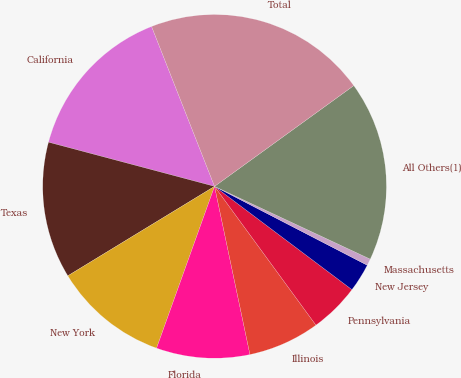Convert chart to OTSL. <chart><loc_0><loc_0><loc_500><loc_500><pie_chart><fcel>California<fcel>Texas<fcel>New York<fcel>Florida<fcel>Illinois<fcel>Pennsylvania<fcel>New Jersey<fcel>Massachusetts<fcel>All Others(1)<fcel>Total<nl><fcel>14.89%<fcel>12.85%<fcel>10.81%<fcel>8.78%<fcel>6.74%<fcel>4.7%<fcel>2.67%<fcel>0.63%<fcel>16.93%<fcel>21.0%<nl></chart> 